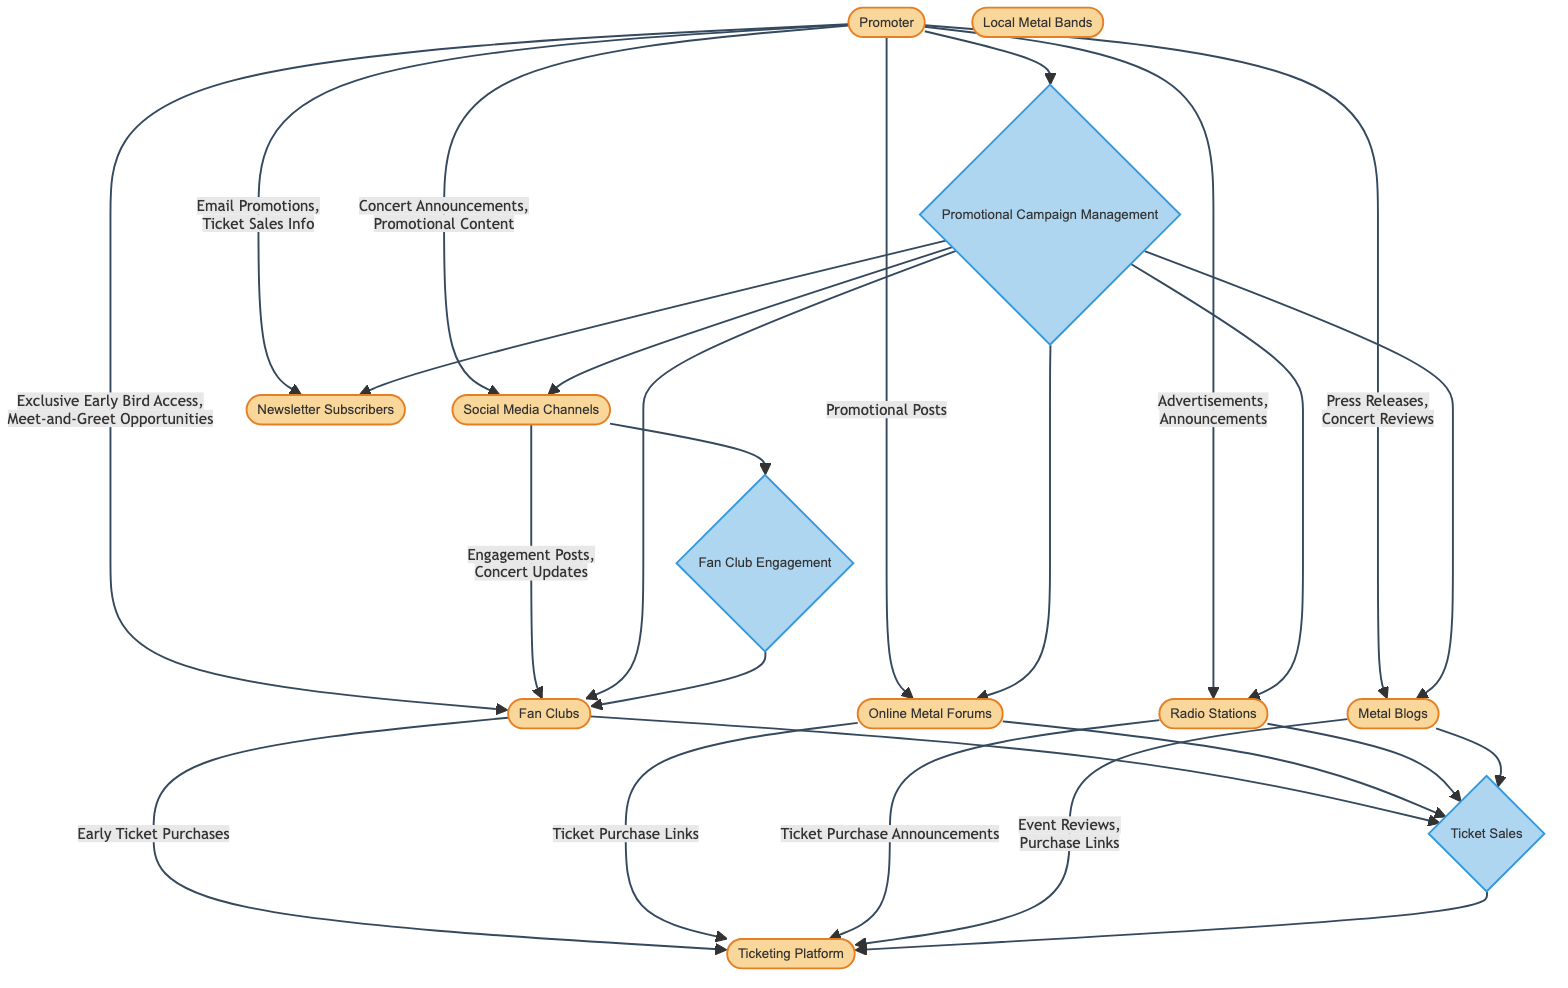What entity receives promotional posts from the promoter? The promoter sends promotional posts directly to the Online Metal Forums according to the data flow. This is indicated by the arrow connecting the Promoter to Online Metal Forums, specifically detailing the data being shared.
Answer: Online Metal Forums How many entities are there in this diagram? Counting each entity represented, there are a total of 9 entities, which include Promoter, Local Metal Bands, Online Metal Forums, Social Media Channels, Ticketing Platform, Fan Clubs, Metal Blogs, Newsletter Subscribers, and Radio Stations.
Answer: 9 What type of promotional material is sent to fan clubs? The promoter provides fan clubs with Exclusive Early Bird Access and Meet-and-Greet Opportunities, as outlined in the data flow from the Promoter to Fan Clubs.
Answer: Exclusive Early Bird Access, Meet-and-Greet Opportunities Which process is responsible for managing ticket sales? The process named "Ticket Sales" is dedicated to handling everything related to the sale of concert tickets, based on the diagram's structure where it is defined and the connections it maintains.
Answer: Ticket Sales What is the relationship between social media channels and fan clubs? Social Media Channels send Engagement Posts and Concert Updates to Fan Clubs, as shown in the data flow pointing from Social Media to Fan Clubs. This indicates the connection and the type of data exchanged.
Answer: Engagement Posts, Concert Updates How many processes are depicted in this diagram? The diagram includes a total of 3 distinct processes: Promotional Campaign Management, Ticket Sales, and Fan Club Engagement, illustrated as separate nodes defined in the processes section.
Answer: 3 What data do radio stations transfer to the ticketing platform? Radio Stations transfer Ticket Purchase Announcements to the Ticketing Platform, as indicated by the data flow that connects Radio Stations to Ticketing, specifying what information is passed along.
Answer: Ticket Purchase Announcements Which entity connects to the ticketing platform via early ticket purchases? The Fan Clubs are noted to connect to the Ticketing Platform specifically for Early Ticket Purchases, which is clearly defined in the data flow from Fan Clubs to Ticketing.
Answer: Fan Clubs What process ensures fan clubs are kept updated? The "Fan Club Engagement" process is responsible for ensuring that fan clubs are continuously updated and engaged, as shown by the connections made from Social Media Channels to Fan Clubs within the diagram.
Answer: Fan Club Engagement 